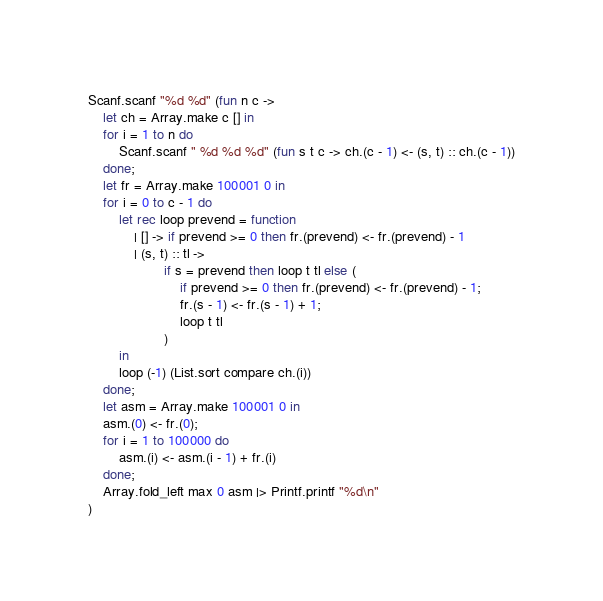Convert code to text. <code><loc_0><loc_0><loc_500><loc_500><_OCaml_>Scanf.scanf "%d %d" (fun n c ->
    let ch = Array.make c [] in
    for i = 1 to n do
        Scanf.scanf " %d %d %d" (fun s t c -> ch.(c - 1) <- (s, t) :: ch.(c - 1))
    done;
    let fr = Array.make 100001 0 in
    for i = 0 to c - 1 do
        let rec loop prevend = function
            | [] -> if prevend >= 0 then fr.(prevend) <- fr.(prevend) - 1
            | (s, t) :: tl ->
                    if s = prevend then loop t tl else (
                        if prevend >= 0 then fr.(prevend) <- fr.(prevend) - 1;
                        fr.(s - 1) <- fr.(s - 1) + 1;
                        loop t tl
                    )
        in
        loop (-1) (List.sort compare ch.(i))
    done;
    let asm = Array.make 100001 0 in
    asm.(0) <- fr.(0);
    for i = 1 to 100000 do
        asm.(i) <- asm.(i - 1) + fr.(i)
    done;
    Array.fold_left max 0 asm |> Printf.printf "%d\n"
)</code> 